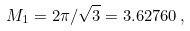<formula> <loc_0><loc_0><loc_500><loc_500>M _ { 1 } = 2 \pi / \sqrt { 3 } = 3 . 6 2 7 6 0 \, ,</formula> 